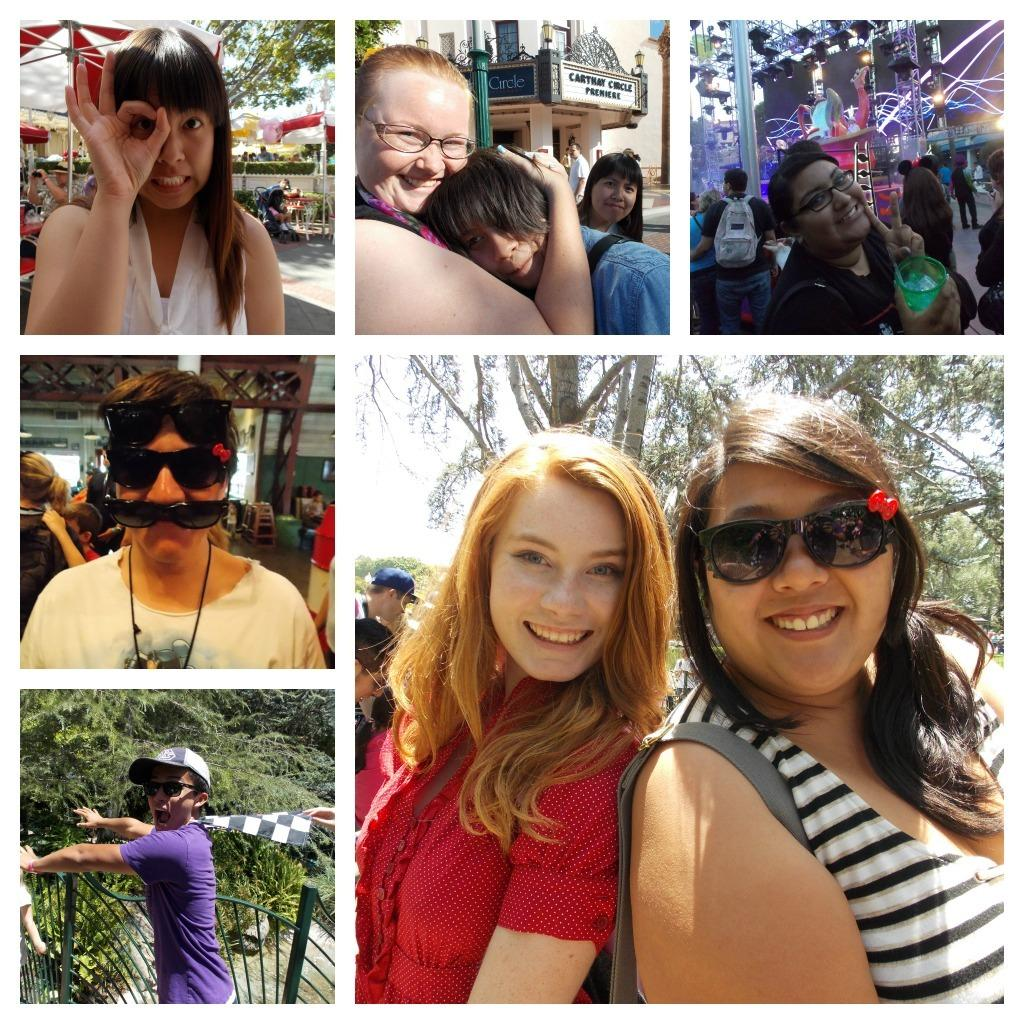What type of image is being described? The image is a collage. What can be found within the collage? There are multiple pictures within the collage. What do the pictures within the collage have in common? Each picture contains people doing different activities. What type of dress is being worn by the person in the wire frame in the image? There is no wire frame or person wearing a dress present in the image; it is a collage of pictures with people doing different activities. 